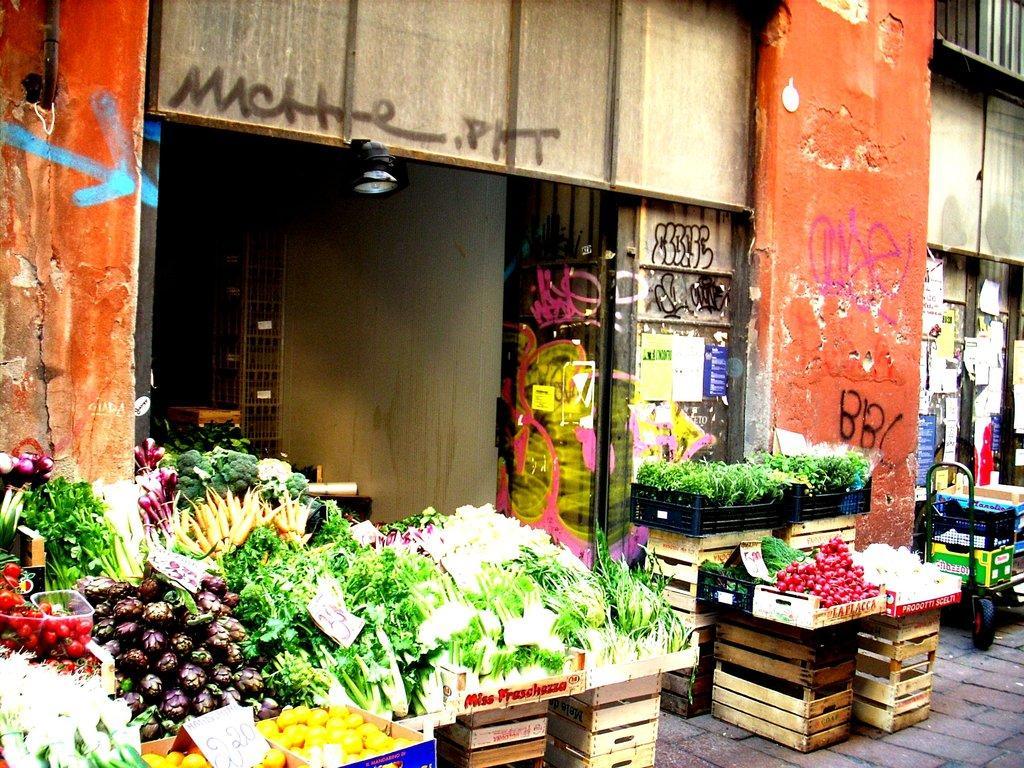Please provide a concise description of this image. In this image I can see so many different type of vegetables served on the table and kept in-front of a building. 